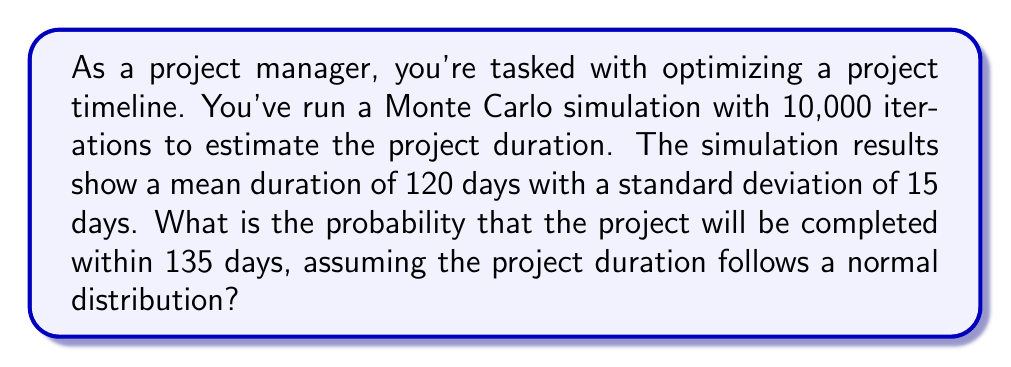Can you solve this math problem? To solve this problem efficiently, we'll use the standard normal distribution (z-score) approach:

1. Calculate the z-score:
   $$z = \frac{x - \mu}{\sigma}$$
   where $x$ is the target duration, $\mu$ is the mean, and $\sigma$ is the standard deviation.

2. Plug in the values:
   $$z = \frac{135 - 120}{15} = 1$$

3. Use a standard normal distribution table or calculator to find the probability for $z \leq 1$.

4. The probability for $z \leq 1$ is approximately 0.8413 or 84.13%.

This means there's an 84.13% chance the project will be completed within 135 days based on the Monte Carlo simulation results.
Answer: 84.13% 